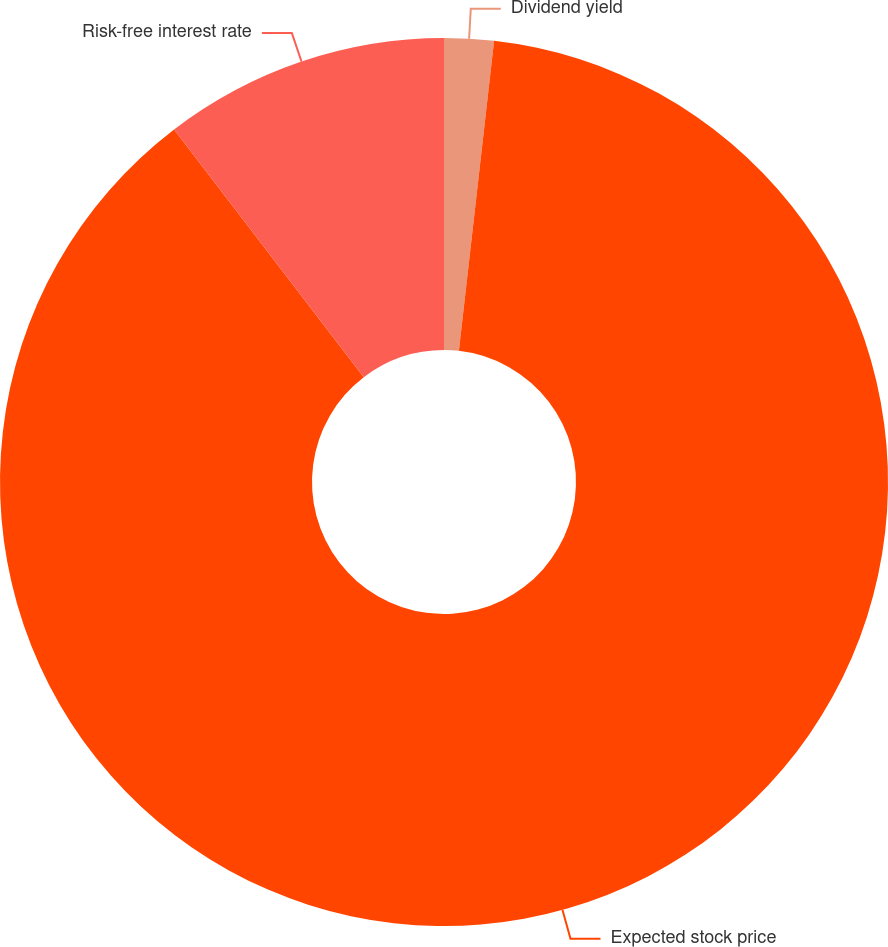Convert chart. <chart><loc_0><loc_0><loc_500><loc_500><pie_chart><fcel>Dividend yield<fcel>Expected stock price<fcel>Risk-free interest rate<nl><fcel>1.8%<fcel>87.8%<fcel>10.4%<nl></chart> 